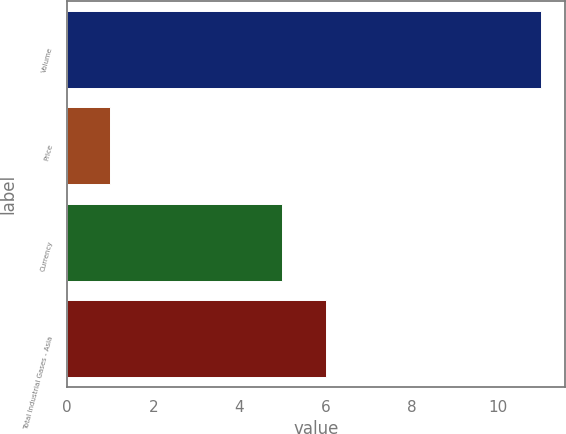Convert chart. <chart><loc_0><loc_0><loc_500><loc_500><bar_chart><fcel>Volume<fcel>Price<fcel>Currency<fcel>Total Industrial Gases - Asia<nl><fcel>11<fcel>1<fcel>5<fcel>6<nl></chart> 